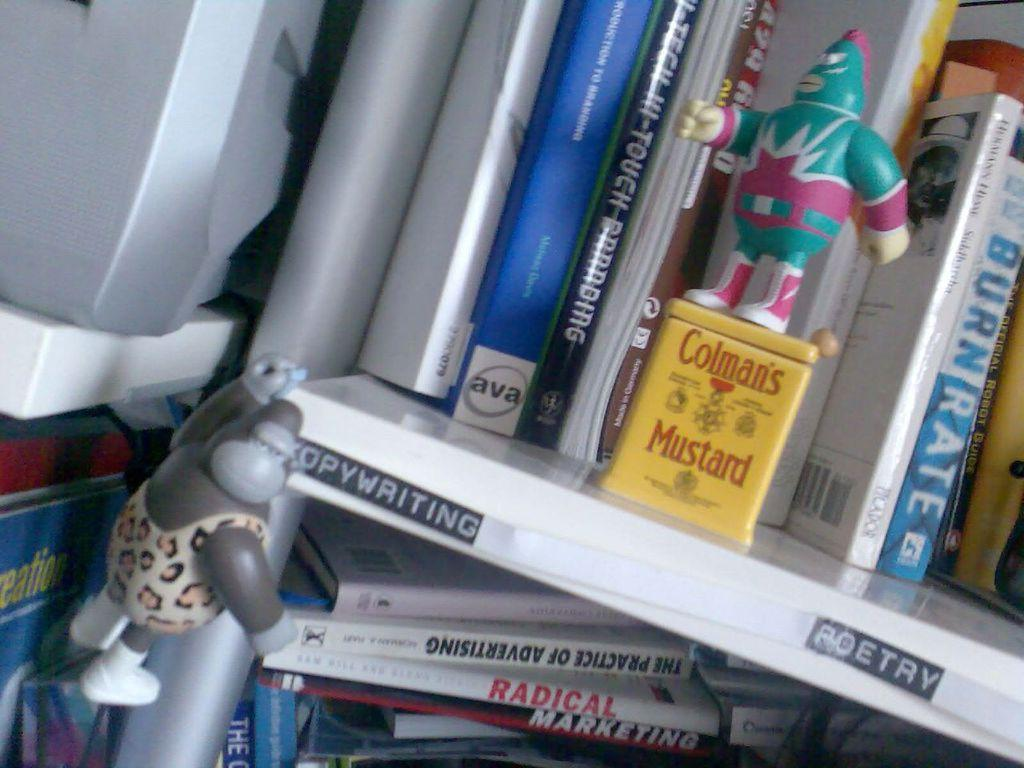<image>
Present a compact description of the photo's key features. A tin of Colman's Mustard on a bookshelf. 